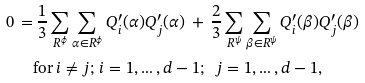Convert formula to latex. <formula><loc_0><loc_0><loc_500><loc_500>0 \, = & \, \frac { 1 } { 3 } \sum _ { R ^ { \phi } } \sum _ { \alpha \in R ^ { \phi } } Q ^ { \prime } _ { i } ( \alpha ) Q ^ { \prime } _ { j } ( \alpha ) \, + \, \frac { 2 } { 3 } \sum _ { R ^ { \psi } } \sum _ { \beta \in R ^ { \psi } } Q ^ { \prime } _ { i } ( \beta ) Q ^ { \prime } _ { j } ( \beta ) \\ & \text {for} \, i \neq j ; \, i = 1 , \dots , d - 1 ; \ \ j = 1 , \dots , d - 1 ,</formula> 